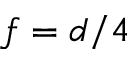Convert formula to latex. <formula><loc_0><loc_0><loc_500><loc_500>f = d / 4</formula> 